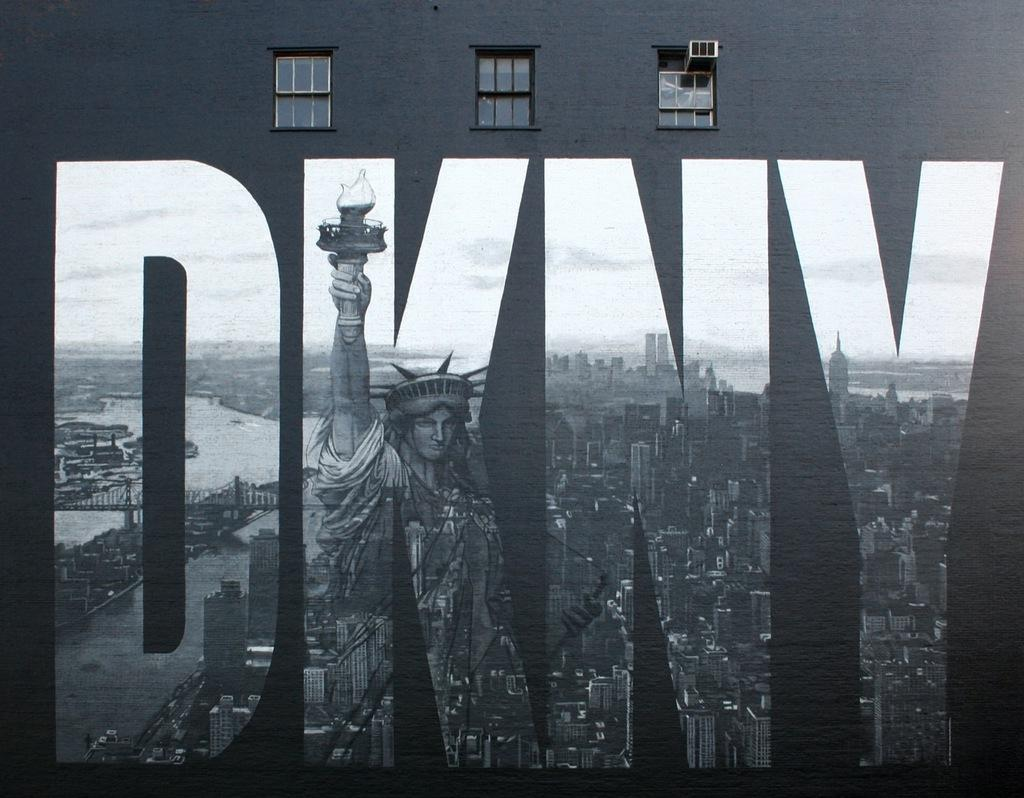What is present on the wall in the image? There is a painting on the wall in the image. What elements are included in the painting? The painting contains a statue, buildings, a bridge, and the sky. How many windows are visible on the wall in the image? There is a wall with windows in the image, but the exact number is not specified. What type of mass can be seen being manipulated with a wrench in the image? There is no mass or wrench present in the image; it features a painting on a wall with windows. How does the painting provide comfort to the viewer in the image? The painting does not provide comfort to the viewer in the image, as it is a static piece of art. 